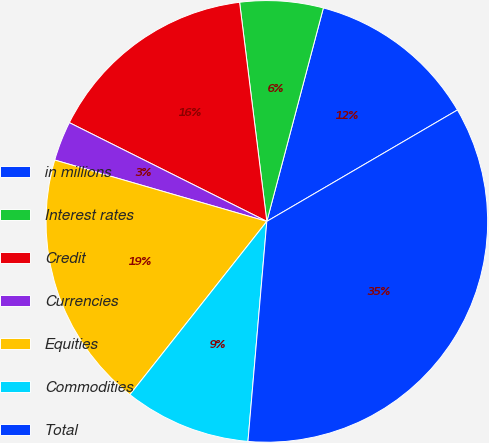<chart> <loc_0><loc_0><loc_500><loc_500><pie_chart><fcel>in millions<fcel>Interest rates<fcel>Credit<fcel>Currencies<fcel>Equities<fcel>Commodities<fcel>Total<nl><fcel>12.46%<fcel>6.09%<fcel>15.65%<fcel>2.9%<fcel>18.84%<fcel>9.28%<fcel>34.78%<nl></chart> 